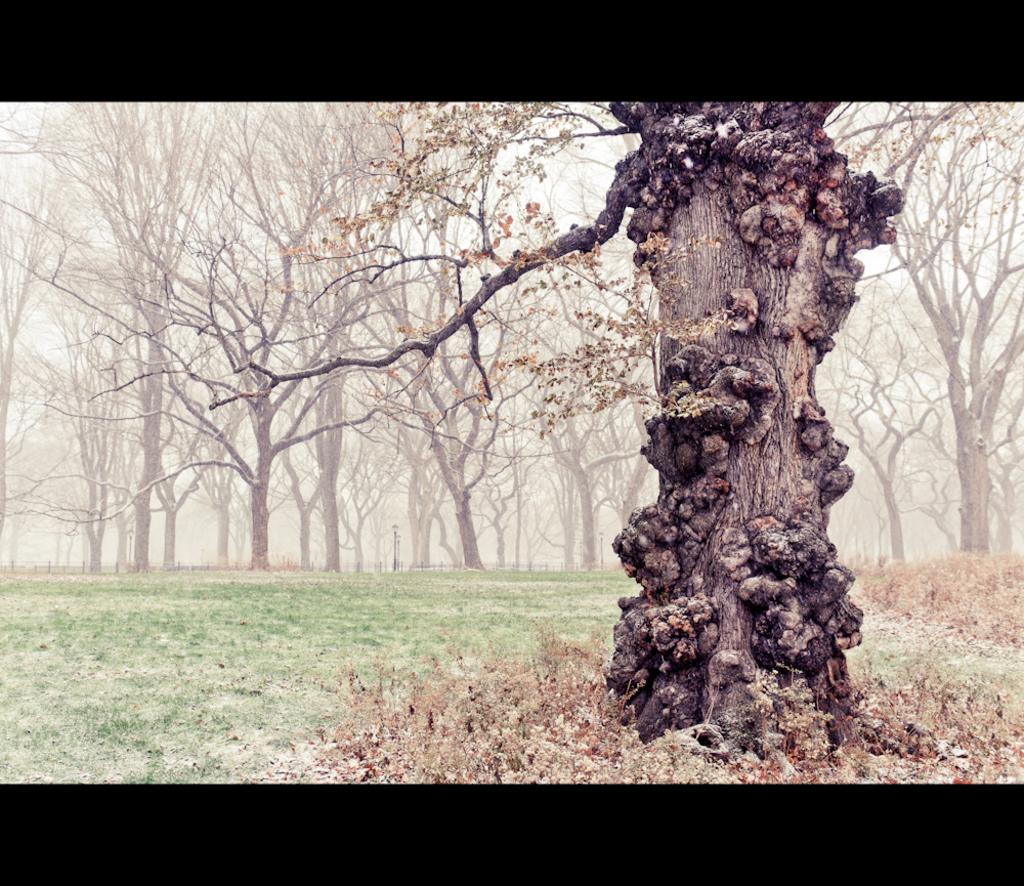What type of vegetation can be seen in the image? There is a group of trees in the image. What else is visible in the image besides the trees? The sky is visible in the image. What type of haircut does the robin have in the image? There is no robin present in the image, so it is not possible to determine the type of haircut it might have. 